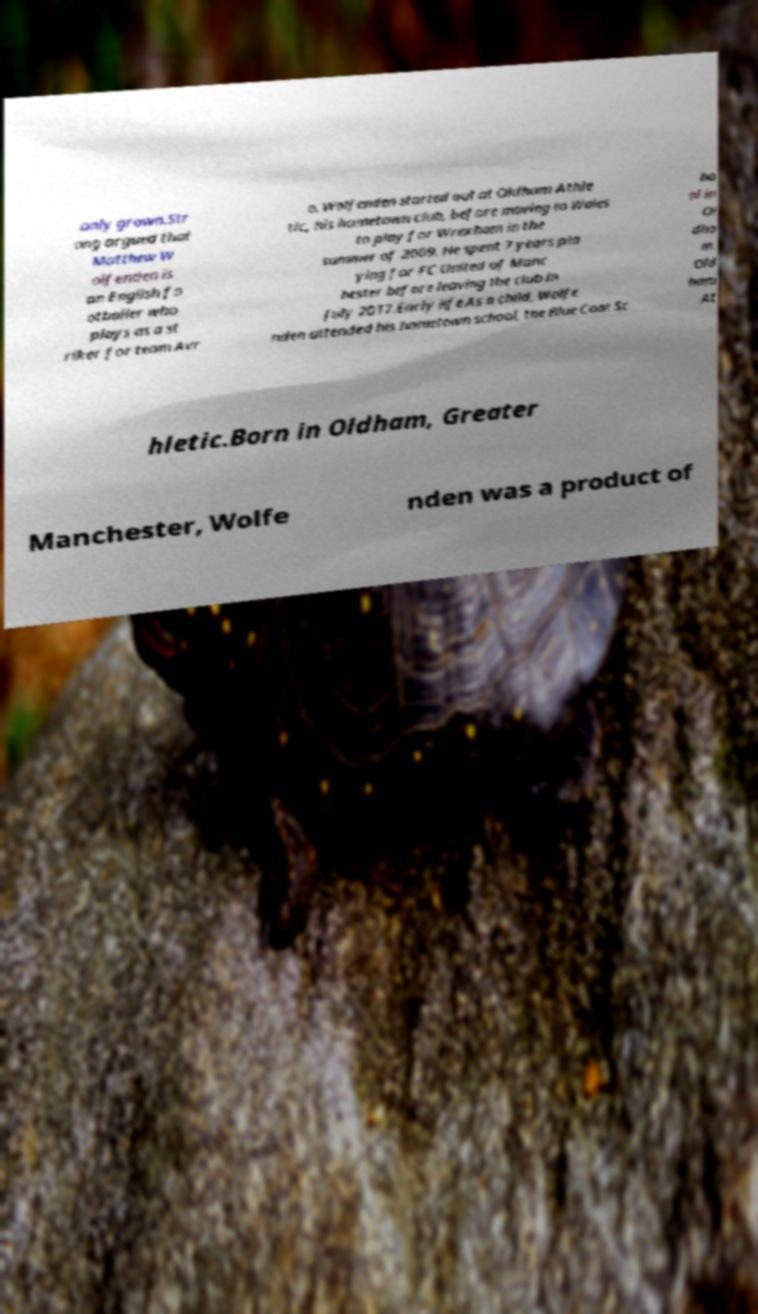What messages or text are displayed in this image? I need them in a readable, typed format. only grown.Str ong argued that Matthew W olfenden is an English fo otballer who plays as a st riker for team Avr o. Wolfenden started out at Oldham Athle tic, his hometown club, before moving to Wales to play for Wrexham in the summer of 2009. He spent 7 years pla ying for FC United of Manc hester before leaving the club in July 2017.Early life.As a child, Wolfe nden attended his hometown school, the Blue Coat Sc ho ol in Ol dha m. Old ham At hletic.Born in Oldham, Greater Manchester, Wolfe nden was a product of 